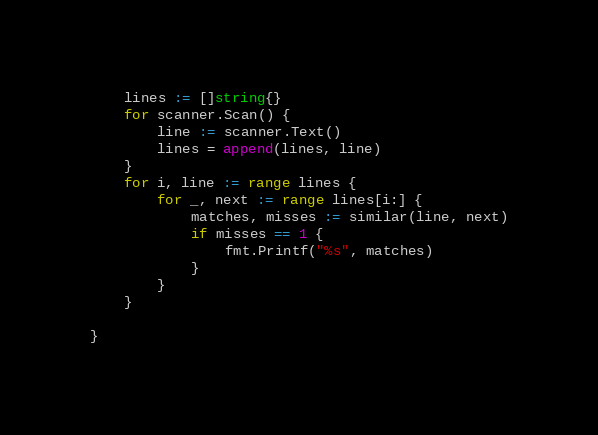<code> <loc_0><loc_0><loc_500><loc_500><_Go_>	lines := []string{}
	for scanner.Scan() {
		line := scanner.Text()
		lines = append(lines, line)
	}
	for i, line := range lines {
		for _, next := range lines[i:] {
			matches, misses := similar(line, next)
			if misses == 1 {
				fmt.Printf("%s", matches)
			}
		}
	}

}
</code> 